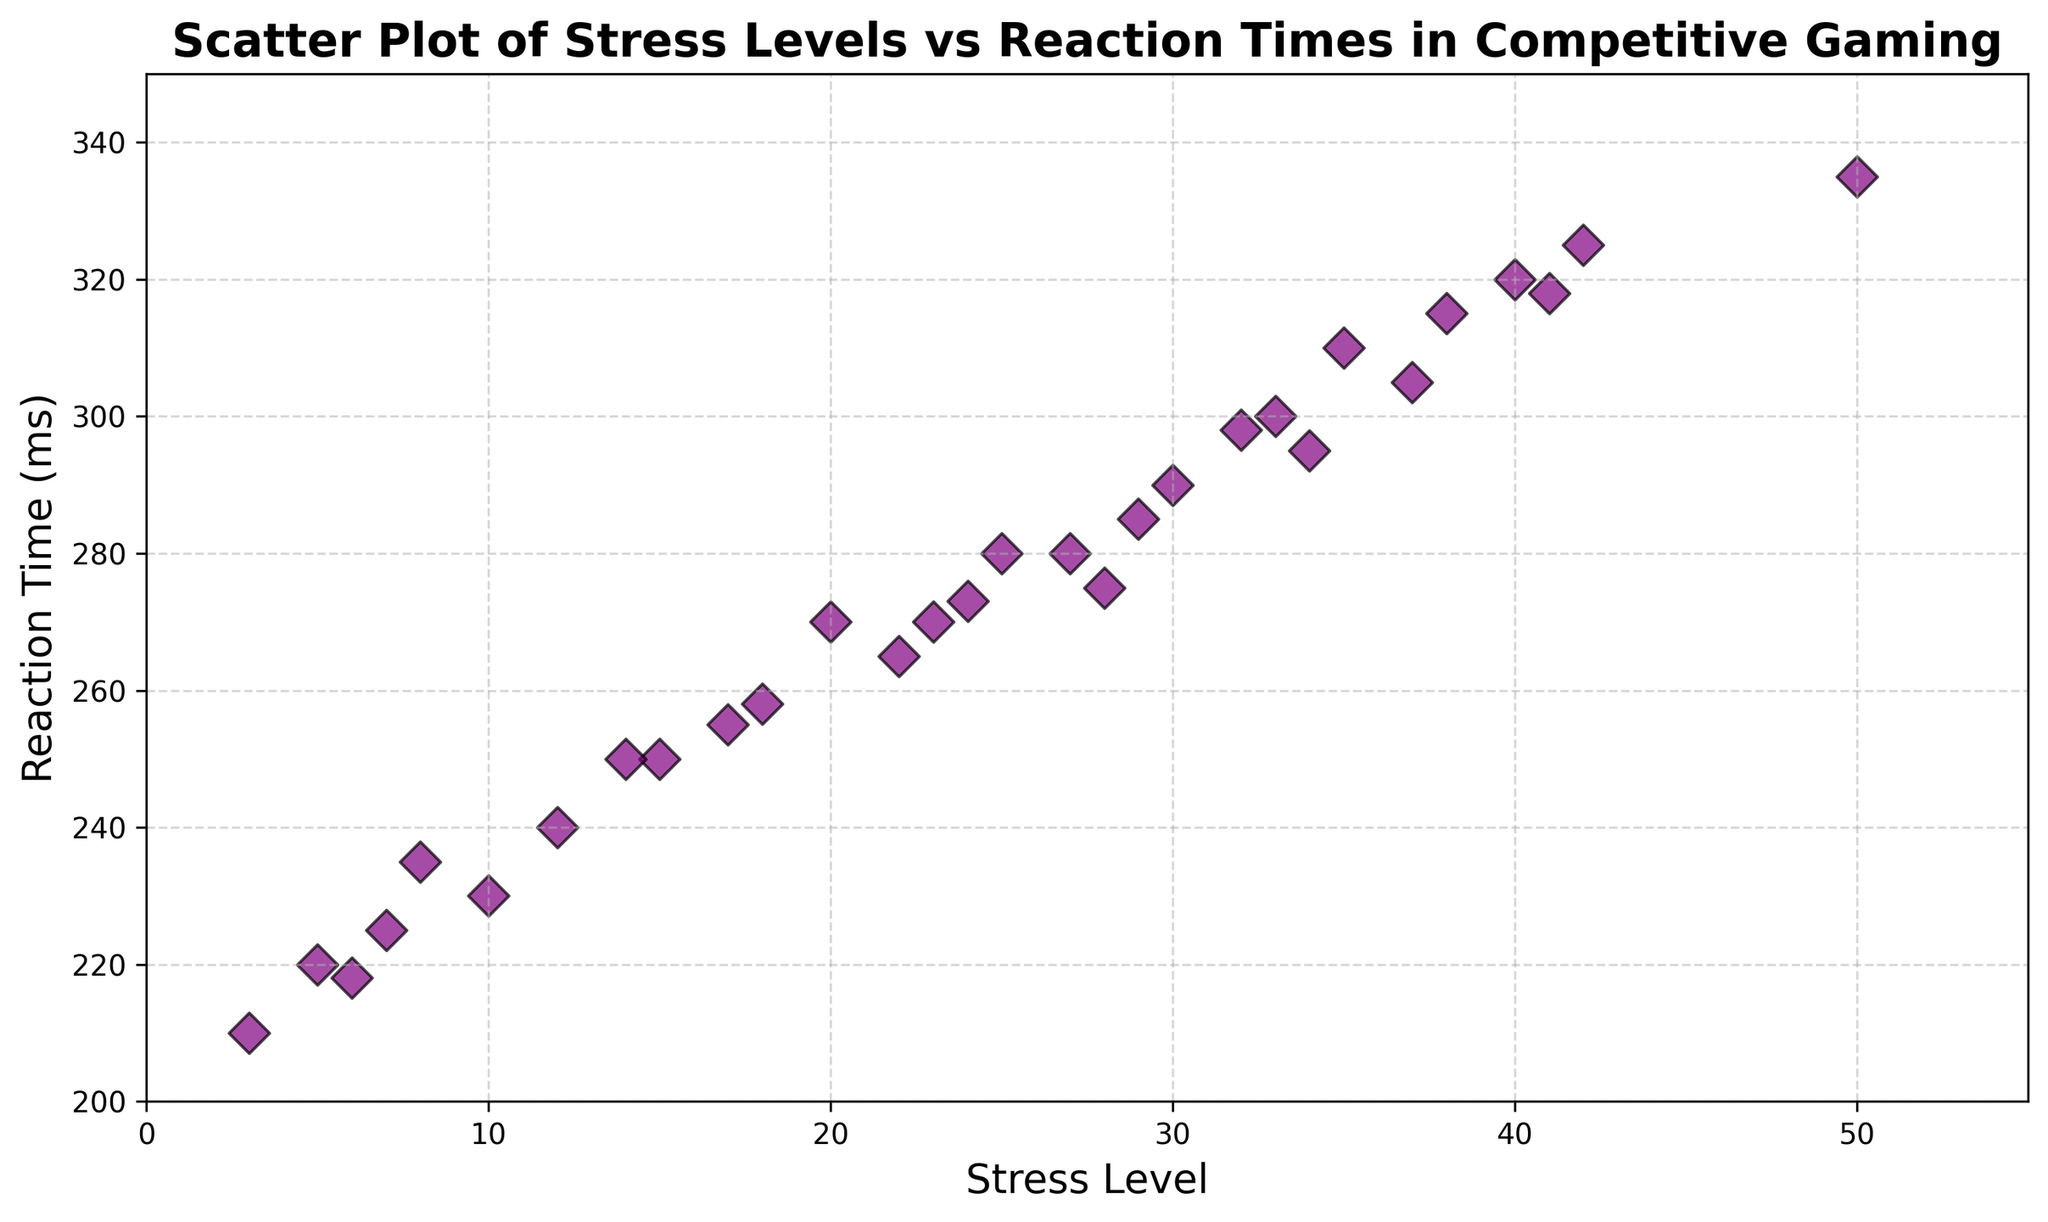What's the general trend observed between stress levels and reaction times in the scatter plot? The scatter plot shows a clear positive trend where increasing stress levels are associated with longer reaction times. This means that as the players' stress levels rise, their reaction times in competitive gaming scenarios tend to increase.
Answer: Positive correlation Which data point has the highest reaction time and what is its stress level? The data point with the highest reaction time is 335 ms, and its corresponding stress level is 50. This can be observed by locating the highest point on the vertical axis and noting its horizontal position.
Answer: Reaction time: 335 ms, Stress level: 50 Which data points have stress levels below 10 and what are their reaction times? By identifying the points located on the left side of the scatter plot where the stress level is below 10, we find the corresponding reaction times. These points are (3, 210), (5, 220), (6, 218), (7, 225), and (8, 235).
Answer: (3, 210), (5, 220), (6, 218), (7, 225), (8, 235) Is there any outlier in terms of reaction time that doesn't follow the general trend? There is no clear outlier that is significantly different from the general trend in the plot. All data points appear to follow the established positive relationship between stress levels and reaction times.
Answer: No clear outlier How many data points have reaction times above 300 ms? To find this, we count the number of data points that lie above the 300 ms line on the vertical axis. These points are (35, 310), (37, 305), (38, 315), (40, 320), (41, 318), (42, 325), and (50, 335).
Answer: 7 data points Which data point has the lowest stress level and what is its reaction time? The data point with the lowest stress level is 3, and its corresponding reaction time is 210 ms. This can be found by looking at the point located at the farthest left on the horizontal axis.
Answer: Stress level: 3, Reaction time: 210 ms What is the average reaction time for stress levels between 20 and 30? First, identify the data points within the stress levels 20 to 30: (22, 265), (24, 273), (25, 280), (27, 280), (28, 275), (29, 285), and (30, 290). Sum their reaction times: 265 + 273 + 280 + 280 + 275 + 285 + 290 = 1948. There are 7 points, so the average reaction time is 1948 / 7 ≈ 278.29 ms.
Answer: 278.29 ms What is the reaction time when the stress level is 40? By locating the data point with a stress level of 40 on the scatter plot, we find that the corresponding reaction time is 320 ms.
Answer: 320 ms Are there any reaction times equal to 250 ms and what are their stress levels? The data points with reaction times of 250 ms have stress levels of 15 and 14. This can be observed by locating these points on the vertical axis and noting their horizontal positions.
Answer: Stress levels: 15 and 14 